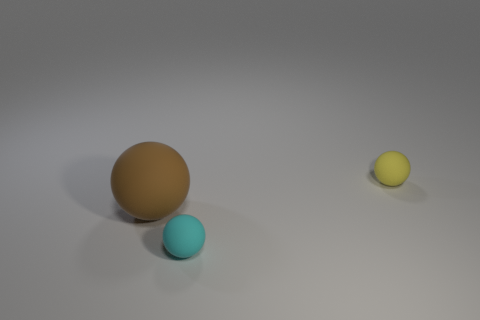There is a tiny object in front of the matte sphere that is right of the tiny matte thing in front of the small yellow matte thing; what is its material?
Keep it short and to the point. Rubber. What number of other things are the same shape as the small yellow rubber object?
Give a very brief answer. 2. What is the color of the thing in front of the brown rubber ball?
Your answer should be compact. Cyan. Are there more yellow matte balls that are to the right of the cyan ball than large green rubber objects?
Your answer should be compact. Yes. How many other objects are there of the same size as the yellow rubber object?
Your response must be concise. 1. What number of things are behind the small cyan object?
Give a very brief answer. 2. Are there an equal number of small cyan rubber balls on the left side of the brown sphere and cyan rubber things that are behind the tiny cyan matte ball?
Keep it short and to the point. Yes. There is a cyan object that is the same shape as the brown matte thing; what size is it?
Your response must be concise. Small. There is a small thing behind the large brown ball; what shape is it?
Your answer should be compact. Sphere. There is a cyan thing; what shape is it?
Your answer should be very brief. Sphere. 